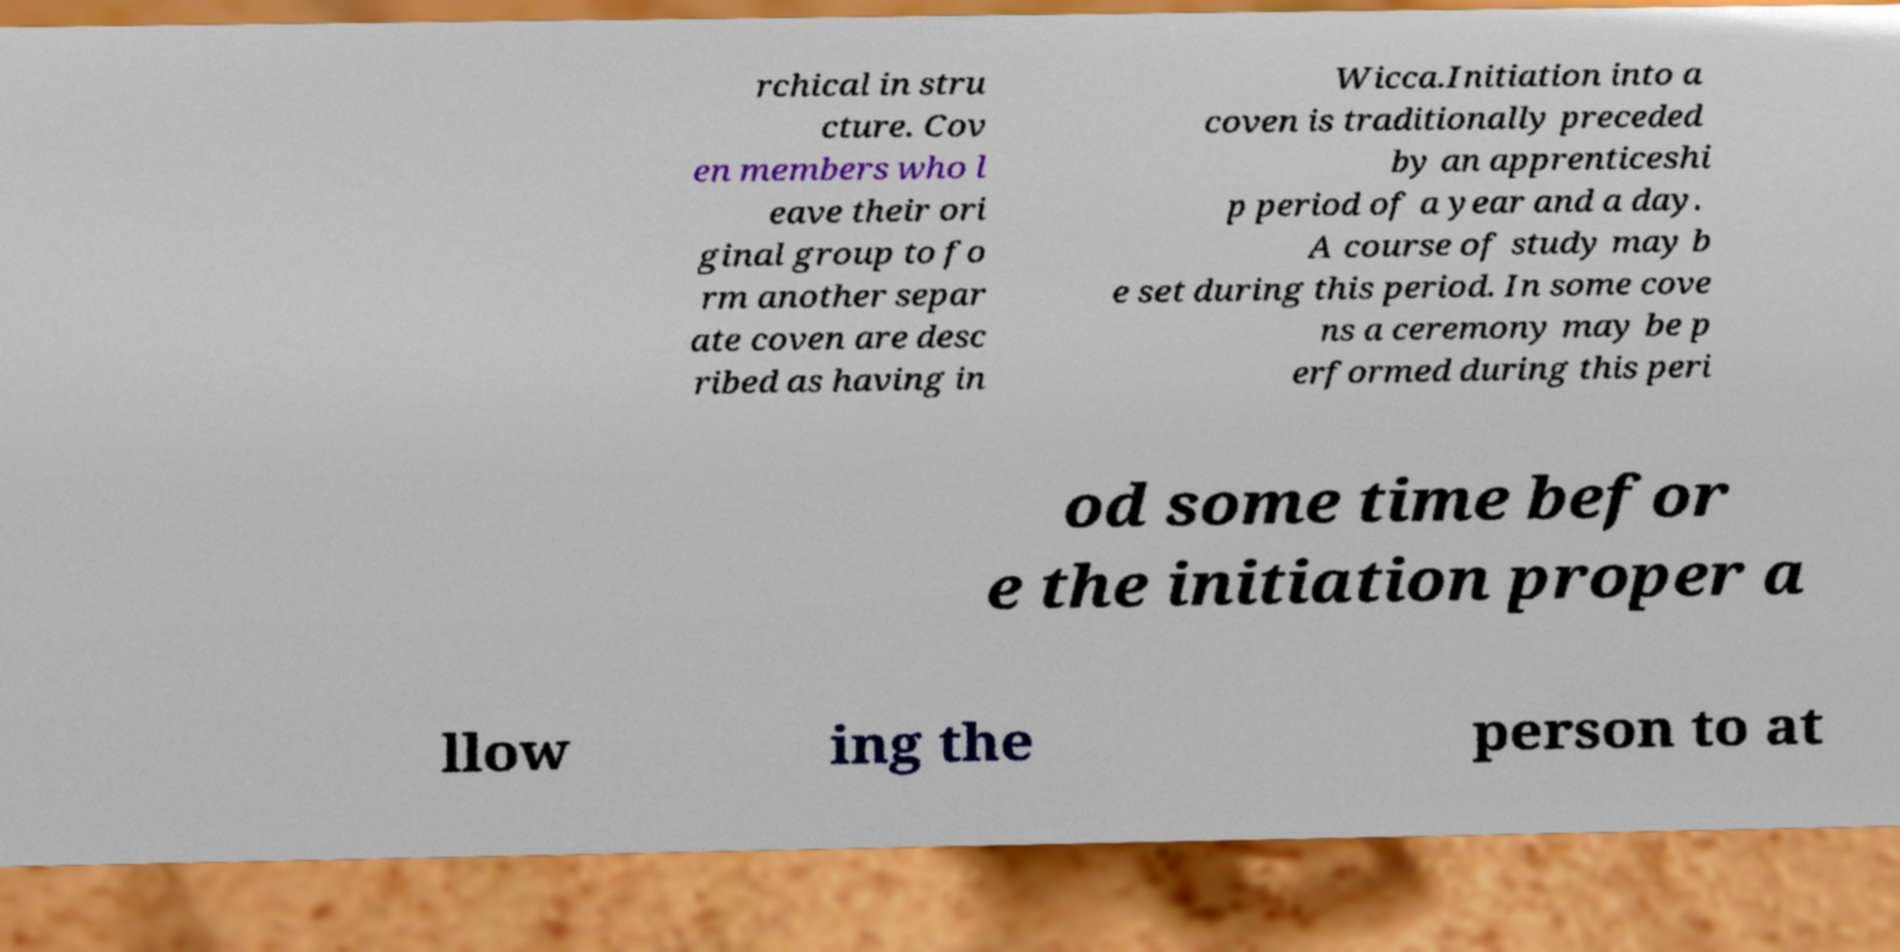Could you extract and type out the text from this image? rchical in stru cture. Cov en members who l eave their ori ginal group to fo rm another separ ate coven are desc ribed as having in Wicca.Initiation into a coven is traditionally preceded by an apprenticeshi p period of a year and a day. A course of study may b e set during this period. In some cove ns a ceremony may be p erformed during this peri od some time befor e the initiation proper a llow ing the person to at 